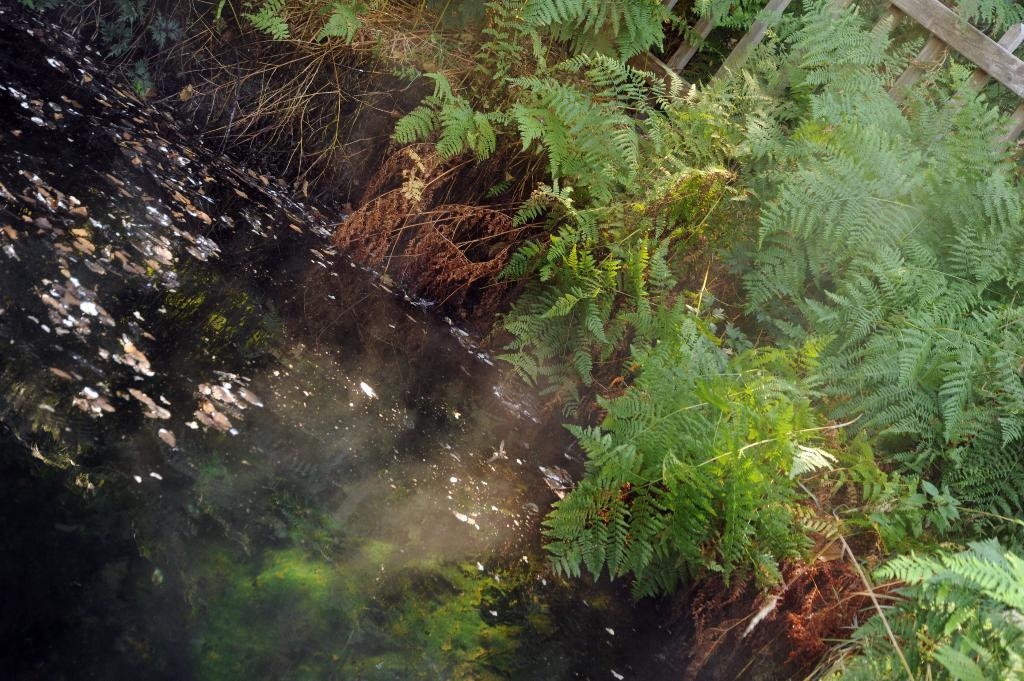What is the primary element in the image? There is water in the image. What can be found floating in the water? There are dried leaves and dust in the water. What type of vegetation is near the water? There are plants near the water. What structure is present in the image? There is a wooden railing in the image. What type of vase is visible in the image? There is no vase present in the image. Can you tell me how many bottles are floating in the water? There are no bottles visible in the image; only dried leaves and dust are present in the water. 